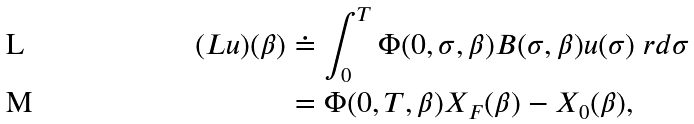Convert formula to latex. <formula><loc_0><loc_0><loc_500><loc_500>( L u ) ( \beta ) & \doteq \int _ { 0 } ^ { T } \Phi ( 0 , \sigma , \beta ) B ( \sigma , \beta ) u ( \sigma ) \ r d \sigma \\ & = \Phi ( 0 , T , \beta ) X _ { F } ( \beta ) - X _ { 0 } ( \beta ) ,</formula> 